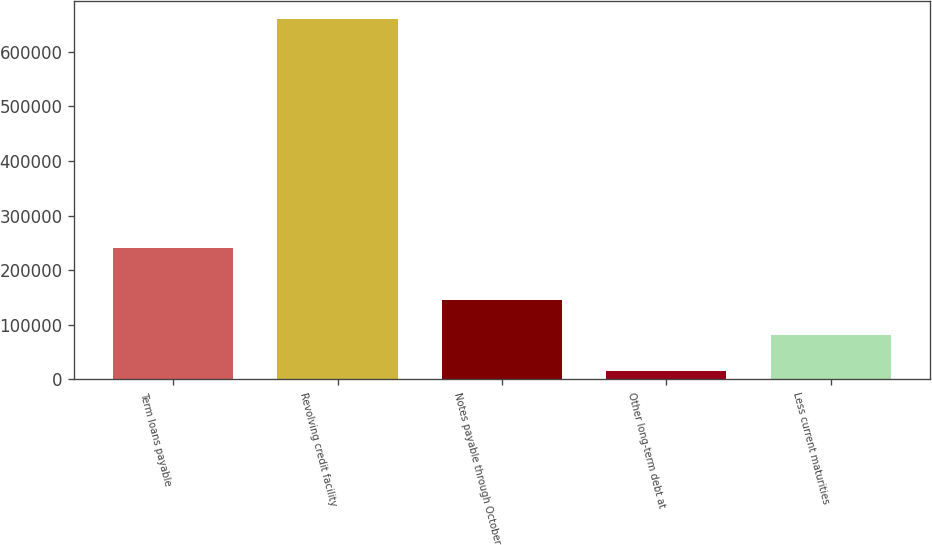Convert chart. <chart><loc_0><loc_0><loc_500><loc_500><bar_chart><fcel>Term loans payable<fcel>Revolving credit facility<fcel>Notes payable through October<fcel>Other long-term debt at<fcel>Less current maturities<nl><fcel>240625<fcel>660730<fcel>145252<fcel>16383<fcel>80817.7<nl></chart> 